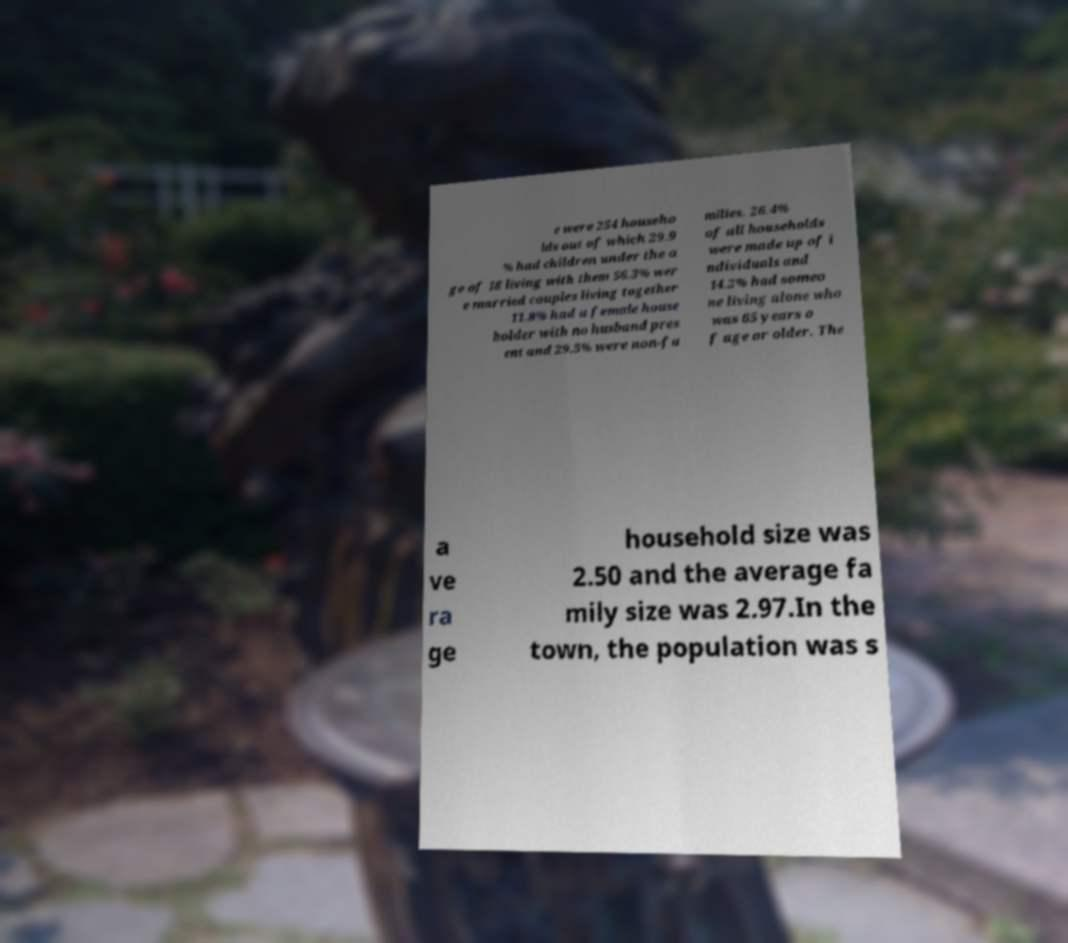Could you extract and type out the text from this image? e were 254 househo lds out of which 29.9 % had children under the a ge of 18 living with them 56.3% wer e married couples living together 11.8% had a female house holder with no husband pres ent and 29.5% were non-fa milies. 26.4% of all households were made up of i ndividuals and 14.2% had someo ne living alone who was 65 years o f age or older. The a ve ra ge household size was 2.50 and the average fa mily size was 2.97.In the town, the population was s 